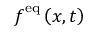<formula> <loc_0><loc_0><loc_500><loc_500>f ^ { e q } \left ( x , t \right )</formula> 